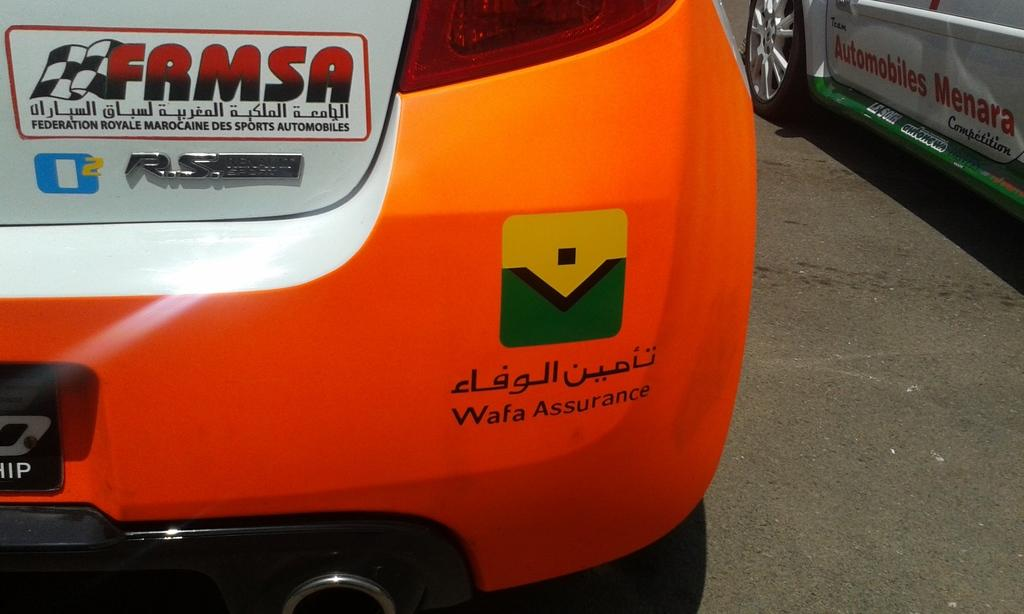How many vehicles can be seen in the image? There are two vehicles in the image. Where are the vehicles located? The vehicles are on the road. What can be found on the vehicles? There is text on the vehicles. What type of mist is surrounding the vehicles in the image? There is no mist present in the image; the vehicles are on a clear road. 